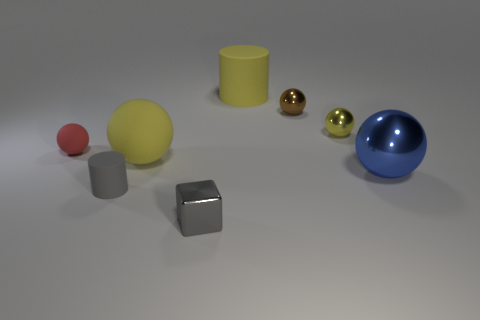Subtract all big blue spheres. How many spheres are left? 4 Add 1 small cyan rubber cylinders. How many objects exist? 9 Subtract all brown balls. How many balls are left? 4 Subtract all balls. How many objects are left? 3 Subtract all tiny brown rubber spheres. Subtract all big rubber balls. How many objects are left? 7 Add 4 tiny yellow spheres. How many tiny yellow spheres are left? 5 Add 6 tiny green cubes. How many tiny green cubes exist? 6 Subtract 0 blue blocks. How many objects are left? 8 Subtract 1 cylinders. How many cylinders are left? 1 Subtract all brown cylinders. Subtract all brown balls. How many cylinders are left? 2 